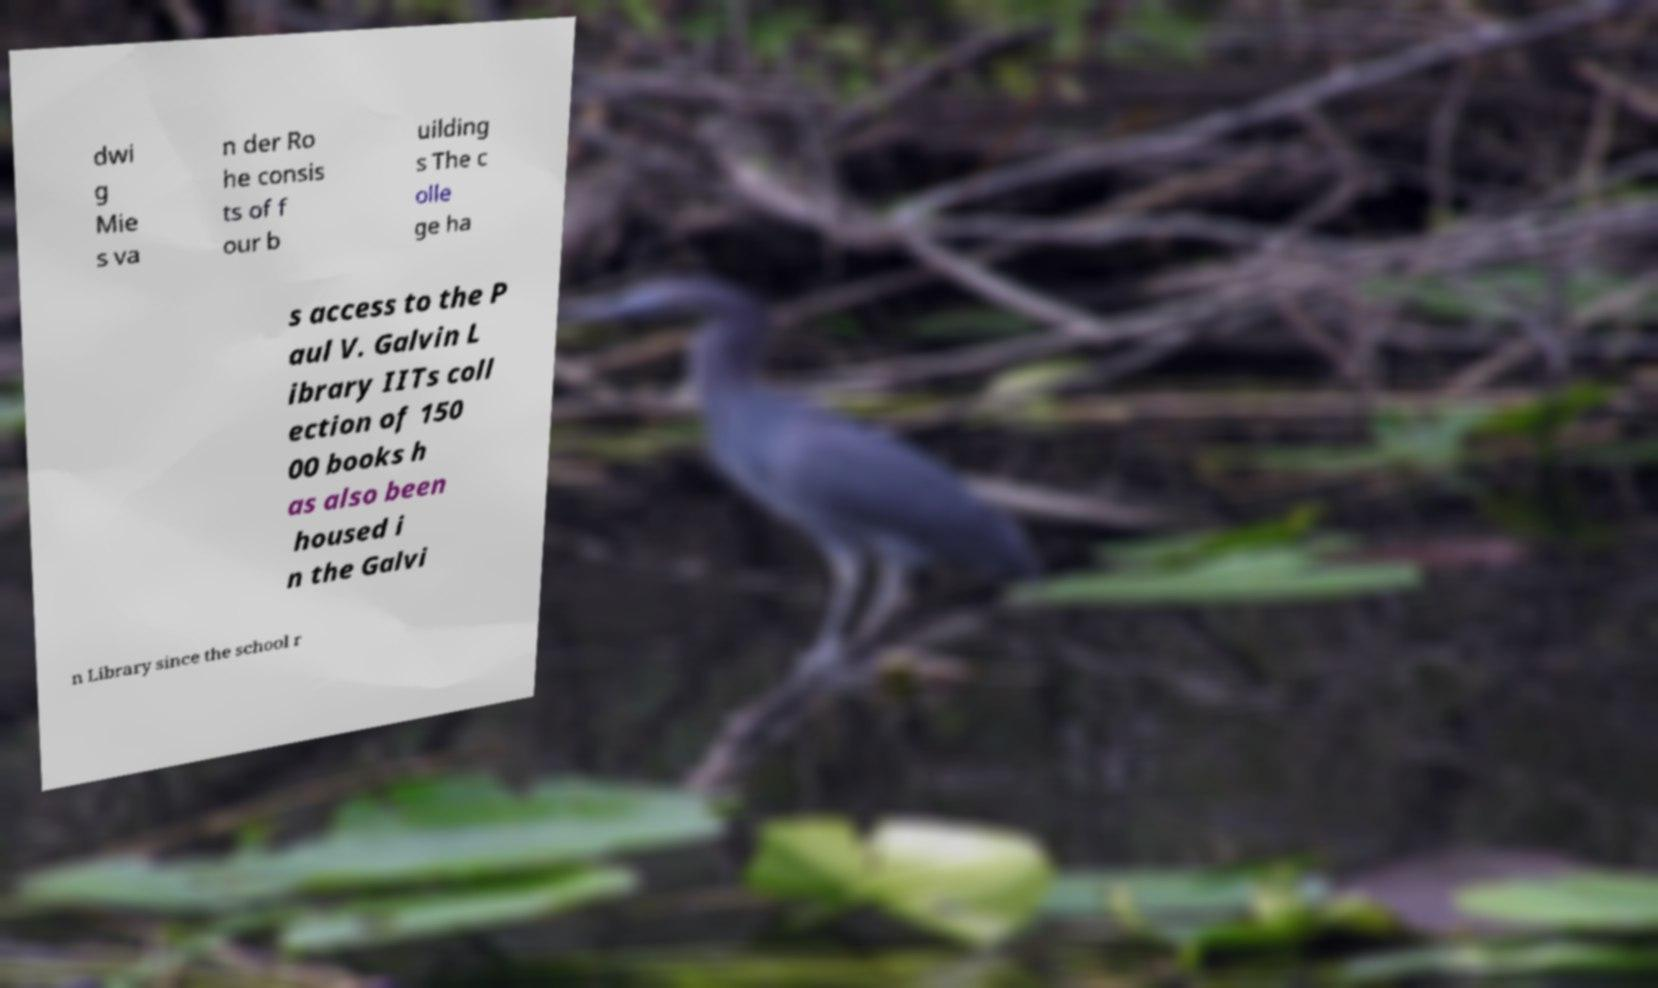Please read and relay the text visible in this image. What does it say? dwi g Mie s va n der Ro he consis ts of f our b uilding s The c olle ge ha s access to the P aul V. Galvin L ibrary IITs coll ection of 150 00 books h as also been housed i n the Galvi n Library since the school r 